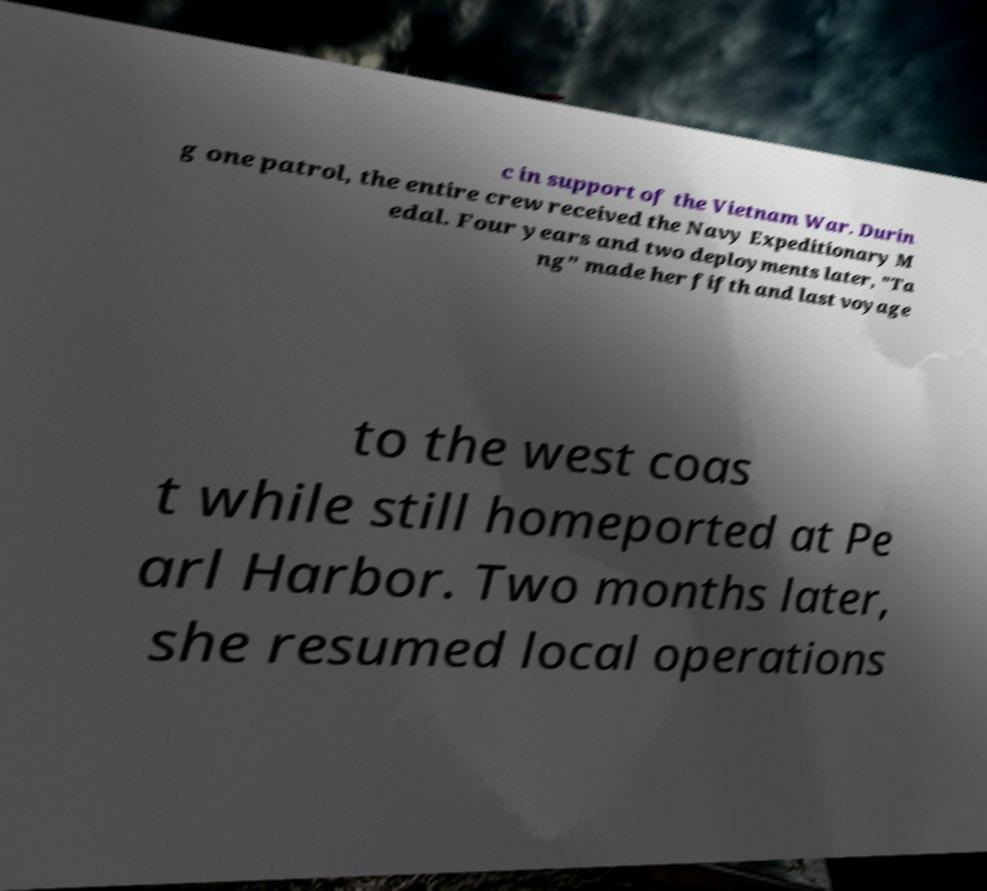What messages or text are displayed in this image? I need them in a readable, typed format. c in support of the Vietnam War. Durin g one patrol, the entire crew received the Navy Expeditionary M edal. Four years and two deployments later, "Ta ng" made her fifth and last voyage to the west coas t while still homeported at Pe arl Harbor. Two months later, she resumed local operations 